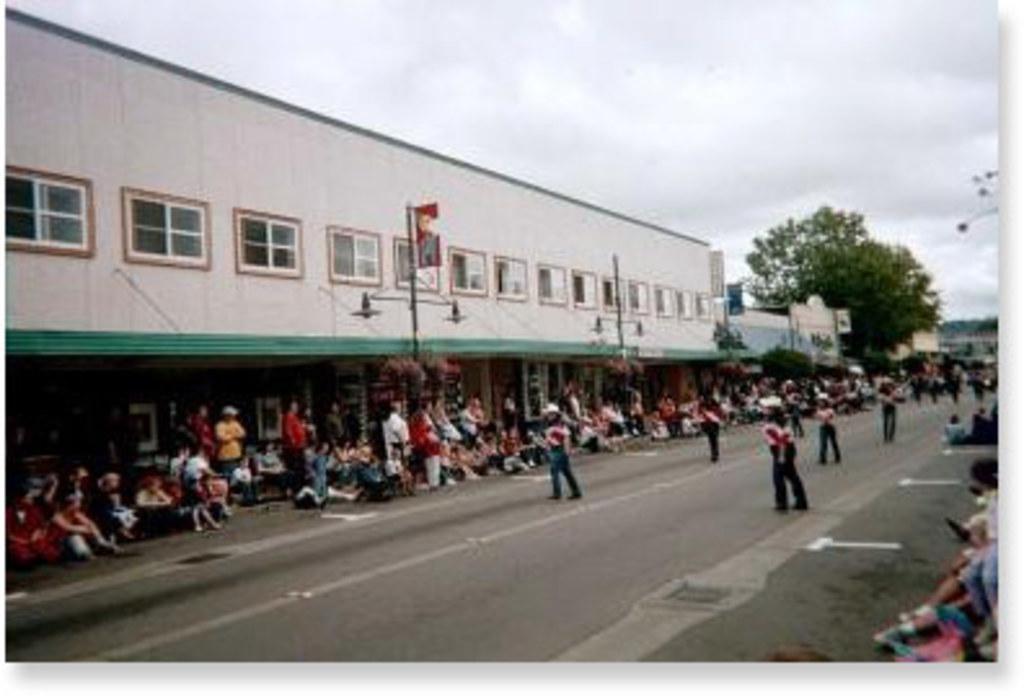Could you give a brief overview of what you see in this image? In this picture we can see a building on the left side, there are some people standing and some people sitting here, in the background there is a tree, we can see the sky at the top of the picture, there is a pole and lights here. 